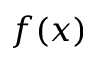<formula> <loc_0><loc_0><loc_500><loc_500>f ( x )</formula> 